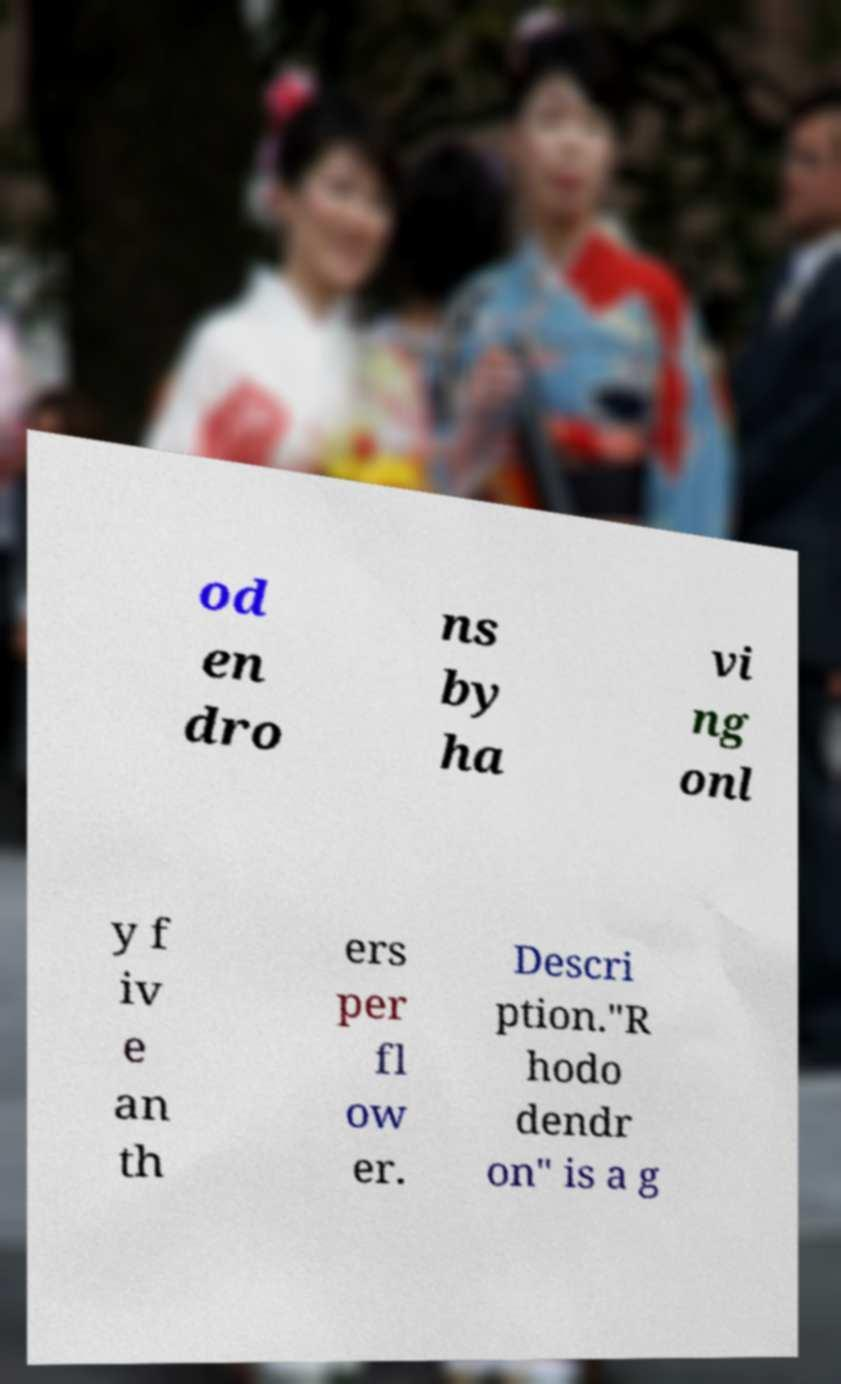What messages or text are displayed in this image? I need them in a readable, typed format. od en dro ns by ha vi ng onl y f iv e an th ers per fl ow er. Descri ption."R hodo dendr on" is a g 